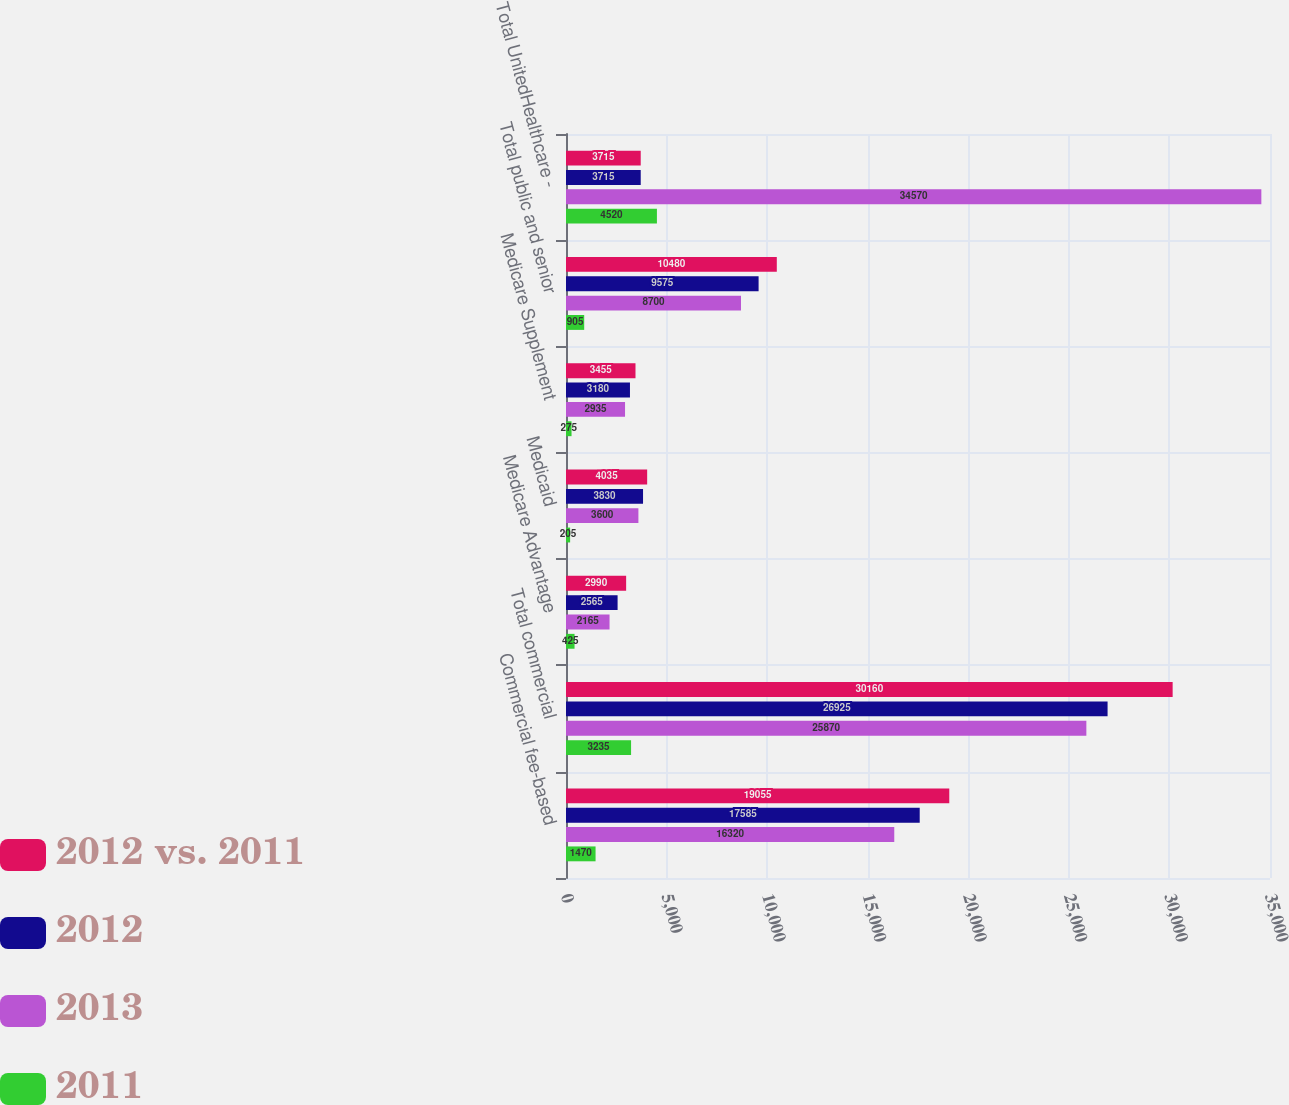Convert chart to OTSL. <chart><loc_0><loc_0><loc_500><loc_500><stacked_bar_chart><ecel><fcel>Commercial fee-based<fcel>Total commercial<fcel>Medicare Advantage<fcel>Medicaid<fcel>Medicare Supplement<fcel>Total public and senior<fcel>Total UnitedHealthcare -<nl><fcel>2012 vs. 2011<fcel>19055<fcel>30160<fcel>2990<fcel>4035<fcel>3455<fcel>10480<fcel>3715<nl><fcel>2012<fcel>17585<fcel>26925<fcel>2565<fcel>3830<fcel>3180<fcel>9575<fcel>3715<nl><fcel>2013<fcel>16320<fcel>25870<fcel>2165<fcel>3600<fcel>2935<fcel>8700<fcel>34570<nl><fcel>2011<fcel>1470<fcel>3235<fcel>425<fcel>205<fcel>275<fcel>905<fcel>4520<nl></chart> 